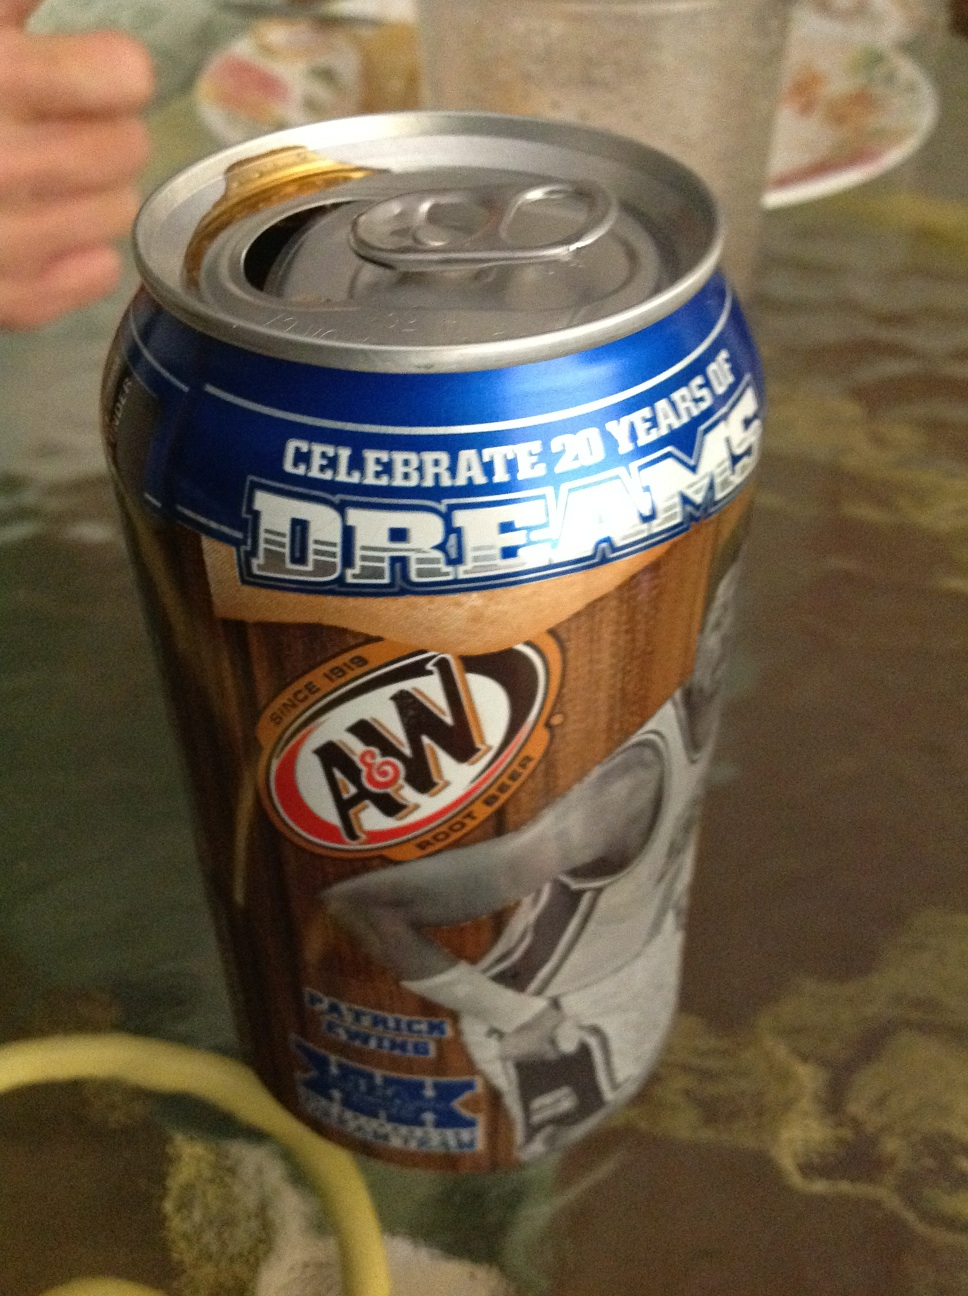Can you think of a slogan related to this A&W Root Beer can? Sip the Dream, Taste the Legacy! 